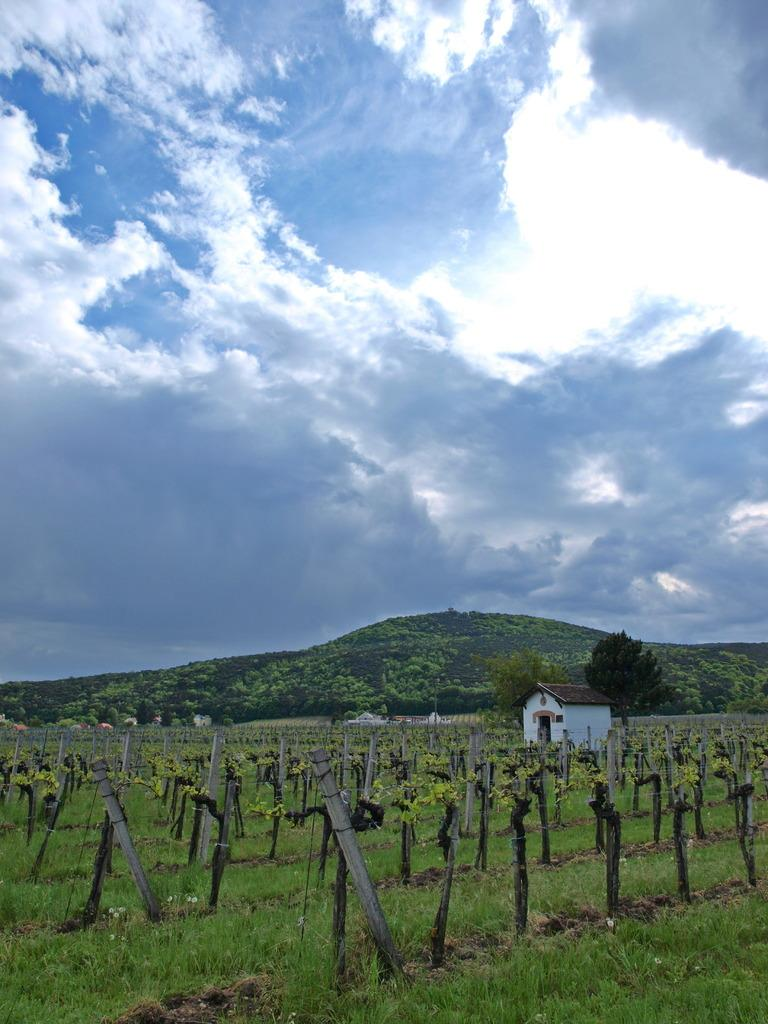What type of landform is present in the image? There is a hill in the image. What type of vegetation can be seen in the image? There are trees in the image. What type of barrier is present in the image? There is fencing in the image. What type of ground cover is present in the image? There is grass in the image. What type of structure is present in the image? There is a house in the image. What is visible in the sky in the image? The sky is visible in the image, and there are clouds present. Can you see a coil of rope on the hill in the image? There is no coil of rope visible on the hill in the image. Is there a hen walking around the house in the image? There is no hen present in the image. 